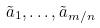Convert formula to latex. <formula><loc_0><loc_0><loc_500><loc_500>\tilde { a } _ { 1 } , \dots , \tilde { a } _ { m / n }</formula> 